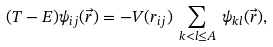Convert formula to latex. <formula><loc_0><loc_0><loc_500><loc_500>( T - E ) \psi _ { i j } ( { \vec { r } } ) = - V ( r _ { i j } ) \, \sum _ { k < l \leq A } \, \psi _ { k l } ( { \vec { r } } ) ,</formula> 